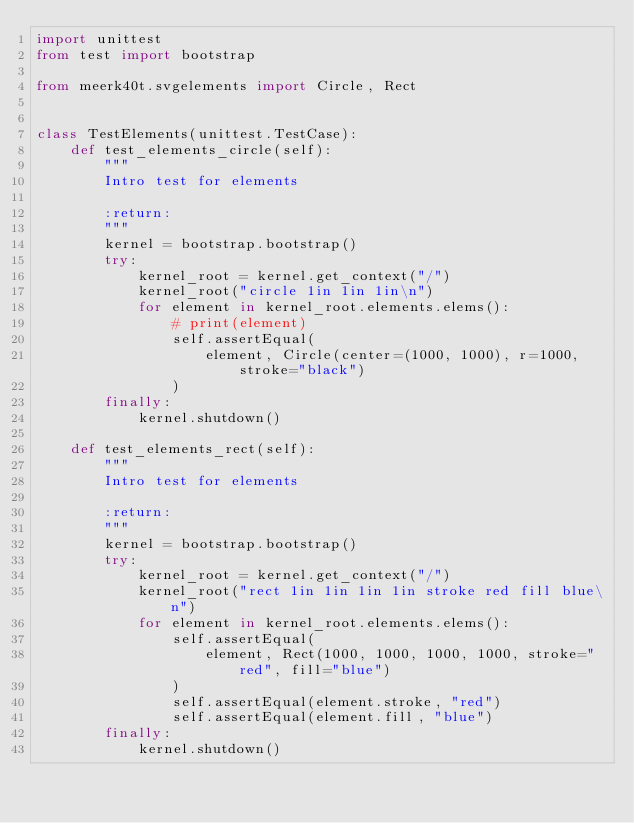Convert code to text. <code><loc_0><loc_0><loc_500><loc_500><_Python_>import unittest
from test import bootstrap

from meerk40t.svgelements import Circle, Rect


class TestElements(unittest.TestCase):
    def test_elements_circle(self):
        """
        Intro test for elements

        :return:
        """
        kernel = bootstrap.bootstrap()
        try:
            kernel_root = kernel.get_context("/")
            kernel_root("circle 1in 1in 1in\n")
            for element in kernel_root.elements.elems():
                # print(element)
                self.assertEqual(
                    element, Circle(center=(1000, 1000), r=1000, stroke="black")
                )
        finally:
            kernel.shutdown()

    def test_elements_rect(self):
        """
        Intro test for elements

        :return:
        """
        kernel = bootstrap.bootstrap()
        try:
            kernel_root = kernel.get_context("/")
            kernel_root("rect 1in 1in 1in 1in stroke red fill blue\n")
            for element in kernel_root.elements.elems():
                self.assertEqual(
                    element, Rect(1000, 1000, 1000, 1000, stroke="red", fill="blue")
                )
                self.assertEqual(element.stroke, "red")
                self.assertEqual(element.fill, "blue")
        finally:
            kernel.shutdown()
</code> 